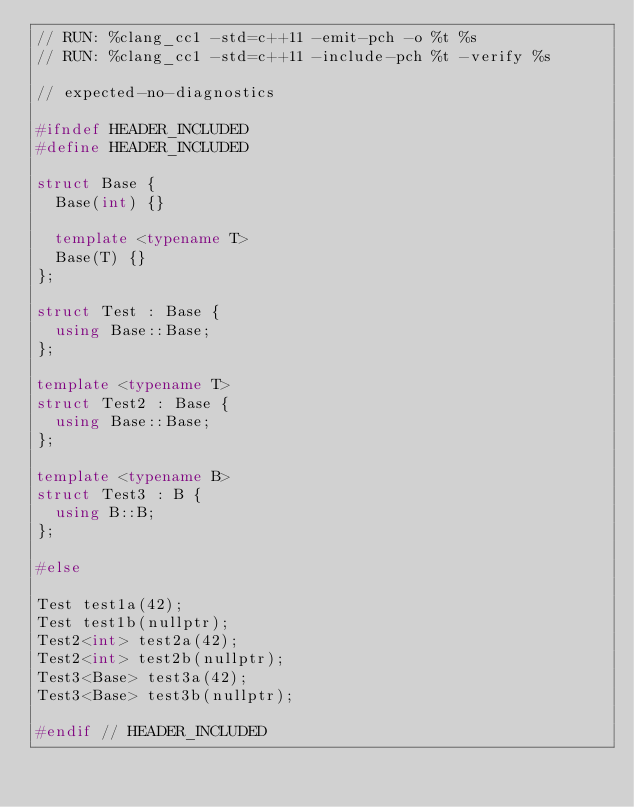<code> <loc_0><loc_0><loc_500><loc_500><_C++_>// RUN: %clang_cc1 -std=c++11 -emit-pch -o %t %s
// RUN: %clang_cc1 -std=c++11 -include-pch %t -verify %s

// expected-no-diagnostics

#ifndef HEADER_INCLUDED
#define HEADER_INCLUDED

struct Base {
  Base(int) {}

  template <typename T>
  Base(T) {}
};

struct Test : Base {
  using Base::Base;
};

template <typename T>
struct Test2 : Base {
  using Base::Base;
};

template <typename B>
struct Test3 : B {
  using B::B;
};

#else

Test test1a(42);
Test test1b(nullptr);
Test2<int> test2a(42);
Test2<int> test2b(nullptr);
Test3<Base> test3a(42);
Test3<Base> test3b(nullptr);

#endif // HEADER_INCLUDED
</code> 